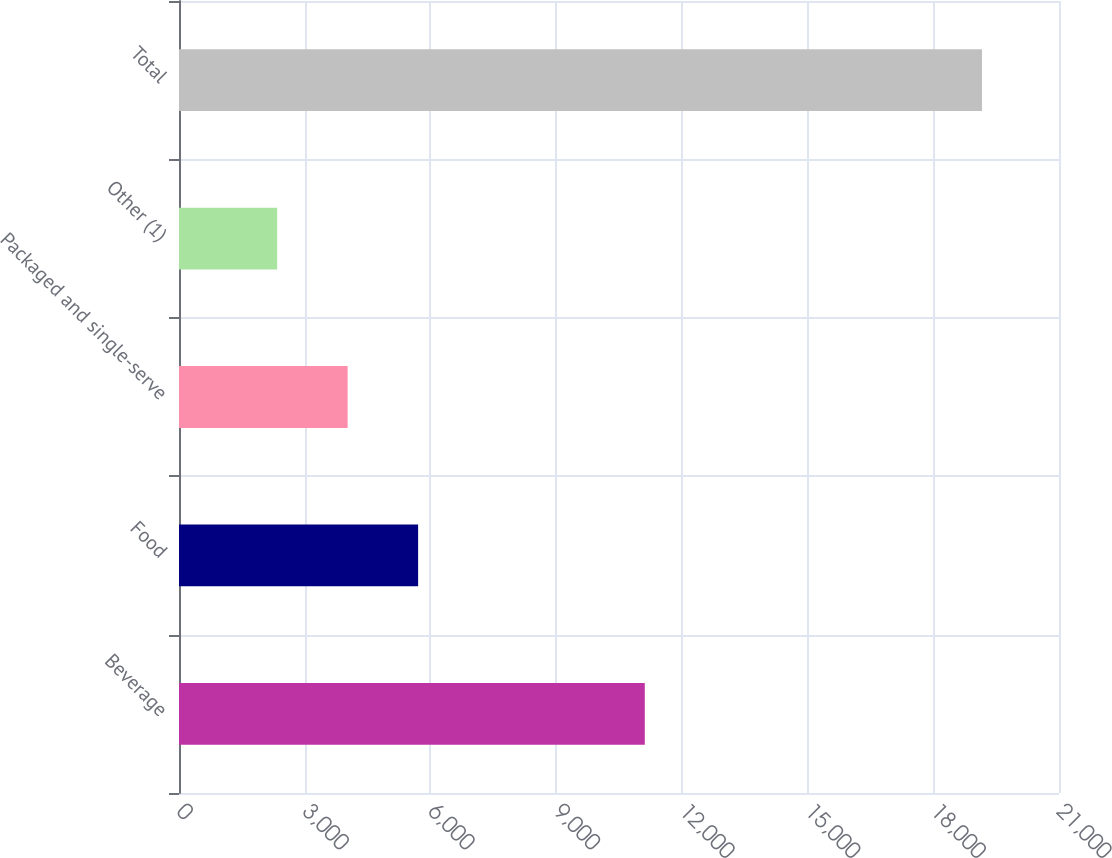Convert chart to OTSL. <chart><loc_0><loc_0><loc_500><loc_500><bar_chart><fcel>Beverage<fcel>Food<fcel>Packaged and single-serve<fcel>Other (1)<fcel>Total<nl><fcel>11115.4<fcel>5706.22<fcel>4024.16<fcel>2342.1<fcel>19162.7<nl></chart> 